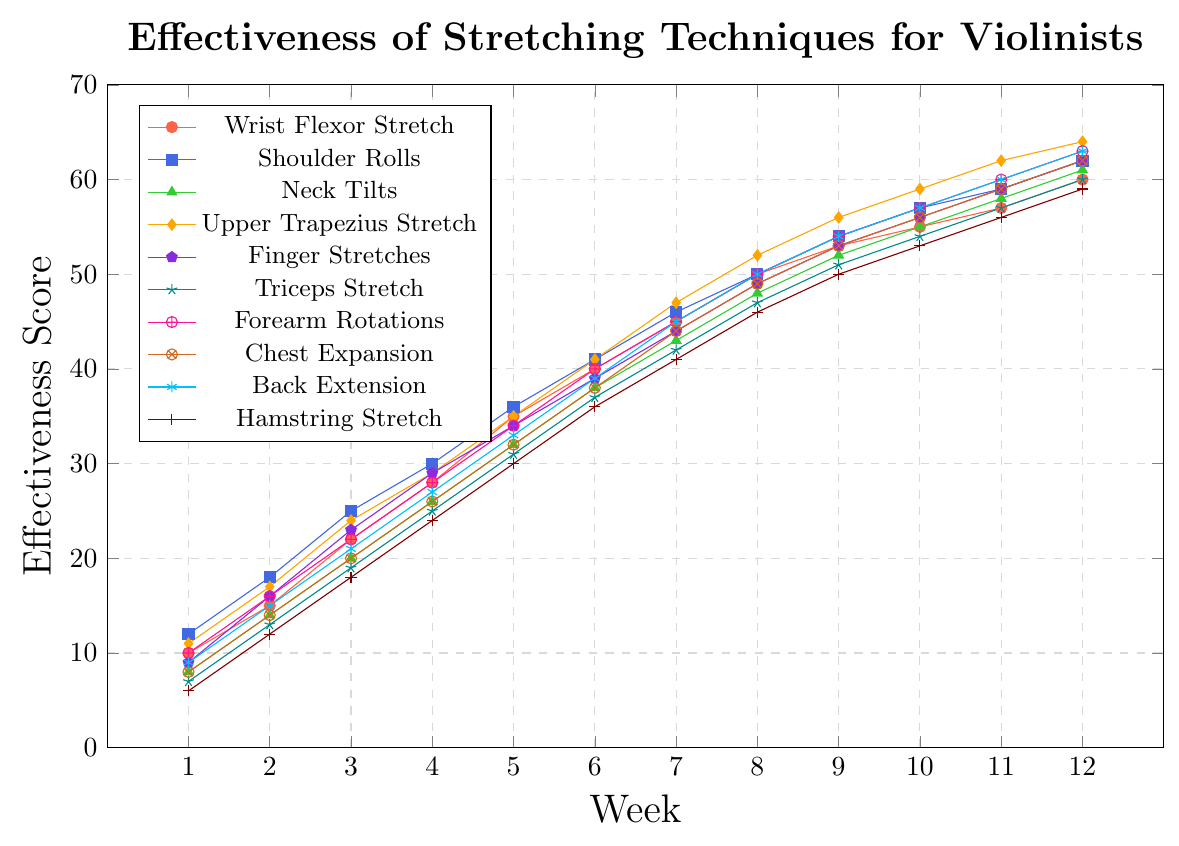Which stretching technique starts with the highest effectiveness score in Week 1? Look at Week 1 on the x-axis and compare the y-values of all stretching techniques. The technique with the highest y-value is Shoulder Rolls at a score of 12.
Answer: Shoulder Rolls What is the total effectiveness score for Neck Tilts over the 12-week period? Sum the effectiveness scores of Neck Tilts for each week: 8+14+20+26+32+38+43+48+52+55+58+61 = 455.
Answer: 455 Which stretching technique has the steepest increase in effectiveness between Week 1 and Week 12? Calculate the difference between the Week 12 score and Week 1 score for each technique and compare: Upper Trapezius Stretch has an increase of 64-11 = 53, which is the largest observed difference.
Answer: Upper Trapezius Stretch Which technique shows the most similar trend to Chest Expansion? Compare the lines visually to see which line is most parallel and closely follows the trend of the Chest Expansion line. Back Extension has a very similar trend to Chest Expansion.
Answer: Back Extension What is the average effectiveness score of the Hamstring Stretch over the first 6 weeks? Add the scores of the Hamstring Stretch from Week 1 to Week 6: 6+12+18+24+30+36 = 126. Divide by 6 to find the average: 126 / 6 = 21.
Answer: 21 Which technique reaches an effectiveness score of 50 first? Track the progress of each line until it hits an effectiveness score of 50 on the y-axis. The Wrist Flexor Stretch reaches 50 at Week 8.
Answer: Wrist Flexor Stretch How does the effectiveness of Forearm Rotations compare to Finger Stretches in Week 10? Look at Week 10 for both techniques on the x-axis and compare the y-values: 57 for Forearm Rotations and 56 for Finger Stretches.
Answer: Forearm Rotations has a higher score What is the difference in effectiveness scores between the Upper Trapezius Stretch and the Hamstring Stretch in the last week? Look at Week 12 scores for both techniques and subtract the Hamstring Stretch score from the Upper Trapezius Stretch score: 64 - 59 = 5.
Answer: 5 Between Weeks 6 and 7, which stretch shows the greatest improvement in effectiveness? Calculate the difference in scores between Week 6 and Week 7 for all techniques and find the largest: Forearm Rotations changes from 40 to 45, showing an improvement of 5, among others.
Answer: Forearm Rotations Do any techniques exhibit the same effectiveness score at any point? Scan the y-values across all weeks to find any equal scores between different techniques. For example, Chest Expansion and Neck Tilts both have scores of 62 in Week 12.
Answer: Yes, Chest Expansion and Neck Tilts in Week 12 